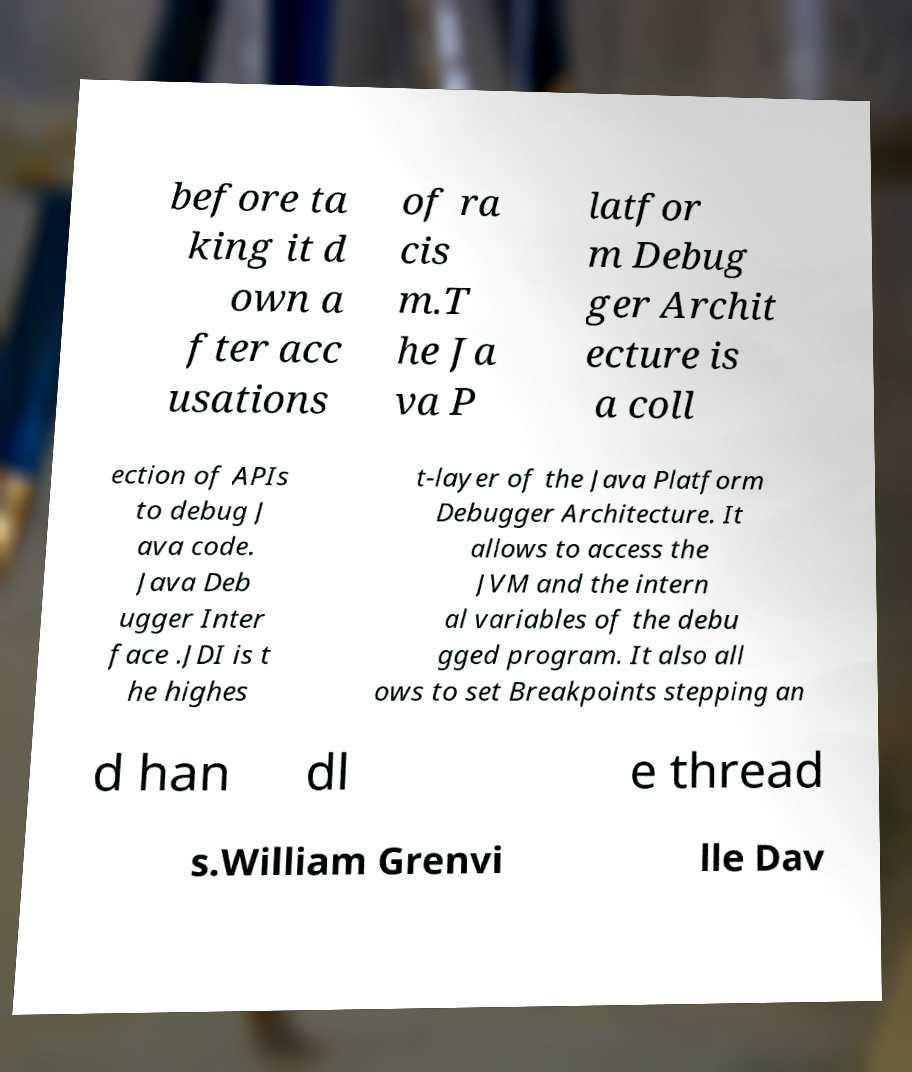For documentation purposes, I need the text within this image transcribed. Could you provide that? before ta king it d own a fter acc usations of ra cis m.T he Ja va P latfor m Debug ger Archit ecture is a coll ection of APIs to debug J ava code. Java Deb ugger Inter face .JDI is t he highes t-layer of the Java Platform Debugger Architecture. It allows to access the JVM and the intern al variables of the debu gged program. It also all ows to set Breakpoints stepping an d han dl e thread s.William Grenvi lle Dav 